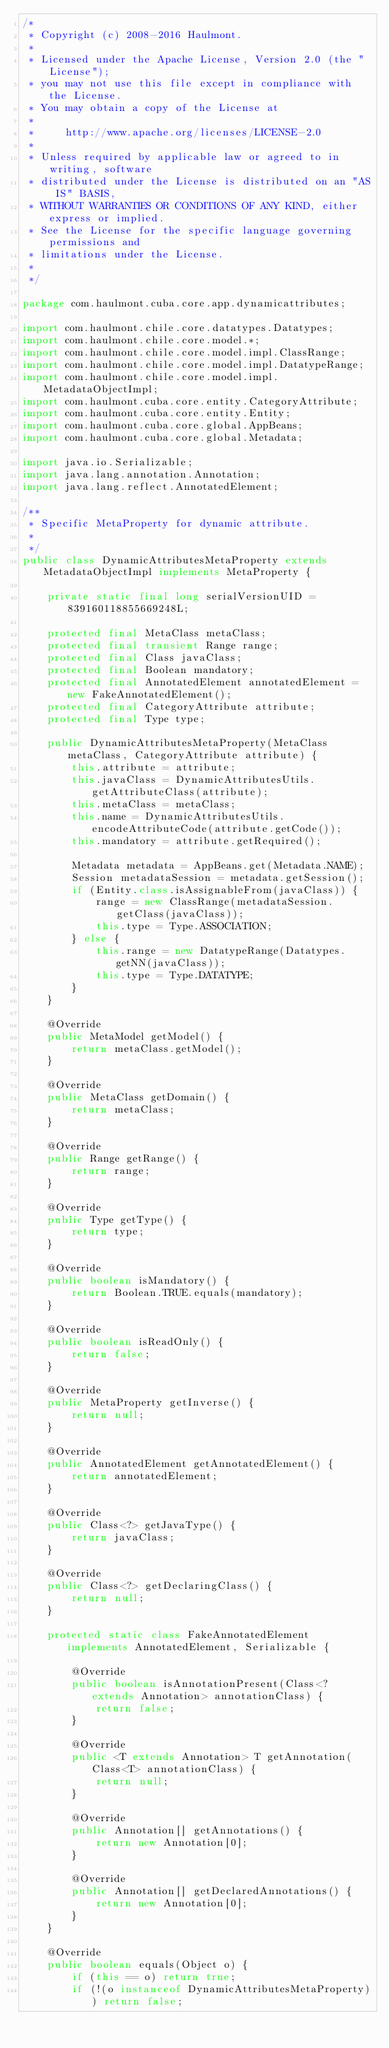Convert code to text. <code><loc_0><loc_0><loc_500><loc_500><_Java_>/*
 * Copyright (c) 2008-2016 Haulmont.
 *
 * Licensed under the Apache License, Version 2.0 (the "License");
 * you may not use this file except in compliance with the License.
 * You may obtain a copy of the License at
 *
 *     http://www.apache.org/licenses/LICENSE-2.0
 *
 * Unless required by applicable law or agreed to in writing, software
 * distributed under the License is distributed on an "AS IS" BASIS,
 * WITHOUT WARRANTIES OR CONDITIONS OF ANY KIND, either express or implied.
 * See the License for the specific language governing permissions and
 * limitations under the License.
 *
 */

package com.haulmont.cuba.core.app.dynamicattributes;

import com.haulmont.chile.core.datatypes.Datatypes;
import com.haulmont.chile.core.model.*;
import com.haulmont.chile.core.model.impl.ClassRange;
import com.haulmont.chile.core.model.impl.DatatypeRange;
import com.haulmont.chile.core.model.impl.MetadataObjectImpl;
import com.haulmont.cuba.core.entity.CategoryAttribute;
import com.haulmont.cuba.core.entity.Entity;
import com.haulmont.cuba.core.global.AppBeans;
import com.haulmont.cuba.core.global.Metadata;

import java.io.Serializable;
import java.lang.annotation.Annotation;
import java.lang.reflect.AnnotatedElement;

/**
 * Specific MetaProperty for dynamic attribute.
 *
 */
public class DynamicAttributesMetaProperty extends MetadataObjectImpl implements MetaProperty {

    private static final long serialVersionUID = 839160118855669248L;

    protected final MetaClass metaClass;
    protected final transient Range range;
    protected final Class javaClass;
    protected final Boolean mandatory;
    protected final AnnotatedElement annotatedElement = new FakeAnnotatedElement();
    protected final CategoryAttribute attribute;
    protected final Type type;

    public DynamicAttributesMetaProperty(MetaClass metaClass, CategoryAttribute attribute) {
        this.attribute = attribute;
        this.javaClass = DynamicAttributesUtils.getAttributeClass(attribute);
        this.metaClass = metaClass;
        this.name = DynamicAttributesUtils.encodeAttributeCode(attribute.getCode());
        this.mandatory = attribute.getRequired();

        Metadata metadata = AppBeans.get(Metadata.NAME);
        Session metadataSession = metadata.getSession();
        if (Entity.class.isAssignableFrom(javaClass)) {
            range = new ClassRange(metadataSession.getClass(javaClass));
            this.type = Type.ASSOCIATION;
        } else {
            this.range = new DatatypeRange(Datatypes.getNN(javaClass));
            this.type = Type.DATATYPE;
        }
    }

    @Override
    public MetaModel getModel() {
        return metaClass.getModel();
    }

    @Override
    public MetaClass getDomain() {
        return metaClass;
    }

    @Override
    public Range getRange() {
        return range;
    }

    @Override
    public Type getType() {
        return type;
    }

    @Override
    public boolean isMandatory() {
        return Boolean.TRUE.equals(mandatory);
    }

    @Override
    public boolean isReadOnly() {
        return false;
    }

    @Override
    public MetaProperty getInverse() {
        return null;
    }

    @Override
    public AnnotatedElement getAnnotatedElement() {
        return annotatedElement;
    }

    @Override
    public Class<?> getJavaType() {
        return javaClass;
    }

    @Override
    public Class<?> getDeclaringClass() {
        return null;
    }

    protected static class FakeAnnotatedElement implements AnnotatedElement, Serializable {

        @Override
        public boolean isAnnotationPresent(Class<? extends Annotation> annotationClass) {
            return false;
        }

        @Override
        public <T extends Annotation> T getAnnotation(Class<T> annotationClass) {
            return null;
        }

        @Override
        public Annotation[] getAnnotations() {
            return new Annotation[0];
        }

        @Override
        public Annotation[] getDeclaredAnnotations() {
            return new Annotation[0];
        }
    }

    @Override
    public boolean equals(Object o) {
        if (this == o) return true;
        if (!(o instanceof DynamicAttributesMetaProperty)) return false;
</code> 